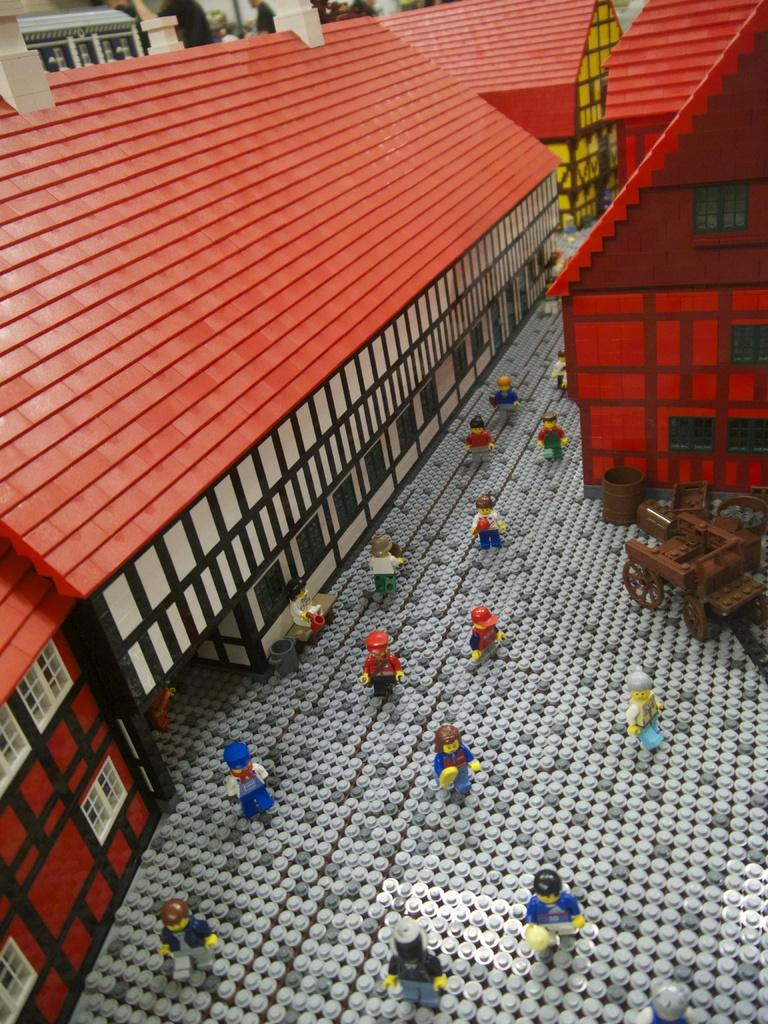What type of puzzle is featured in the image? There is a LEGO puzzle in the image. What elements are included in the LEGO puzzle? The LEGO puzzle includes buildings, people, a wheel cart, and other objects. Can you hear a whistle in the image? There is no whistle present in the image; it is a still image of a LEGO puzzle. 